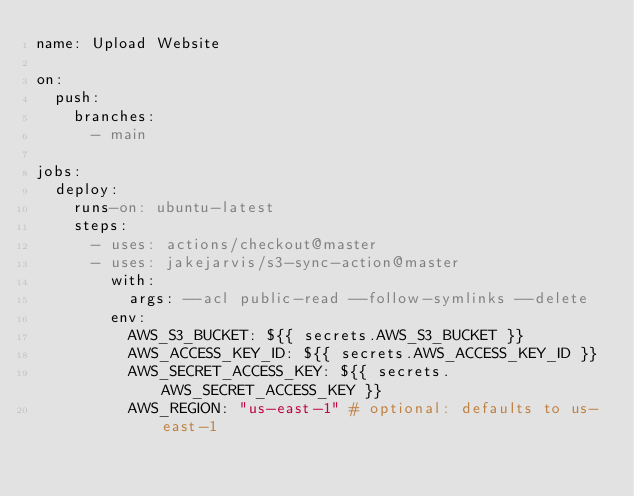<code> <loc_0><loc_0><loc_500><loc_500><_YAML_>name: Upload Website

on:
  push:
    branches:
      - main

jobs:
  deploy:
    runs-on: ubuntu-latest
    steps:
      - uses: actions/checkout@master
      - uses: jakejarvis/s3-sync-action@master
        with:
          args: --acl public-read --follow-symlinks --delete
        env:
          AWS_S3_BUCKET: ${{ secrets.AWS_S3_BUCKET }}
          AWS_ACCESS_KEY_ID: ${{ secrets.AWS_ACCESS_KEY_ID }}
          AWS_SECRET_ACCESS_KEY: ${{ secrets.AWS_SECRET_ACCESS_KEY }}
          AWS_REGION: "us-east-1" # optional: defaults to us-east-1
</code> 